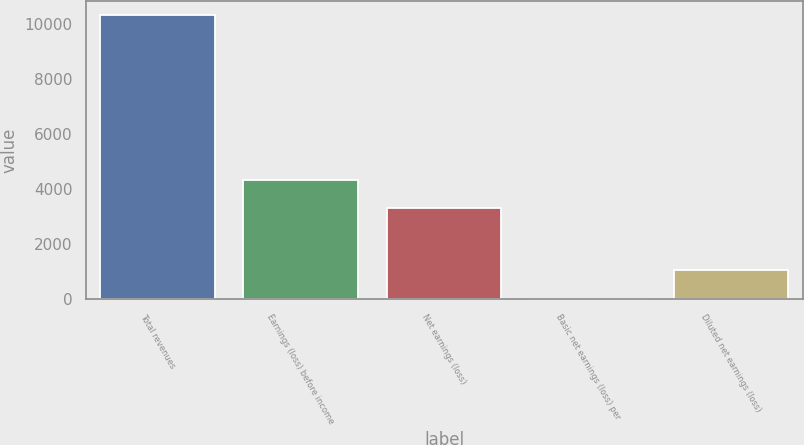<chart> <loc_0><loc_0><loc_500><loc_500><bar_chart><fcel>Total revenues<fcel>Earnings (loss) before income<fcel>Net earnings (loss)<fcel>Basic net earnings (loss) per<fcel>Diluted net earnings (loss)<nl><fcel>10304<fcel>4331.75<fcel>3302<fcel>6.52<fcel>1036.27<nl></chart> 